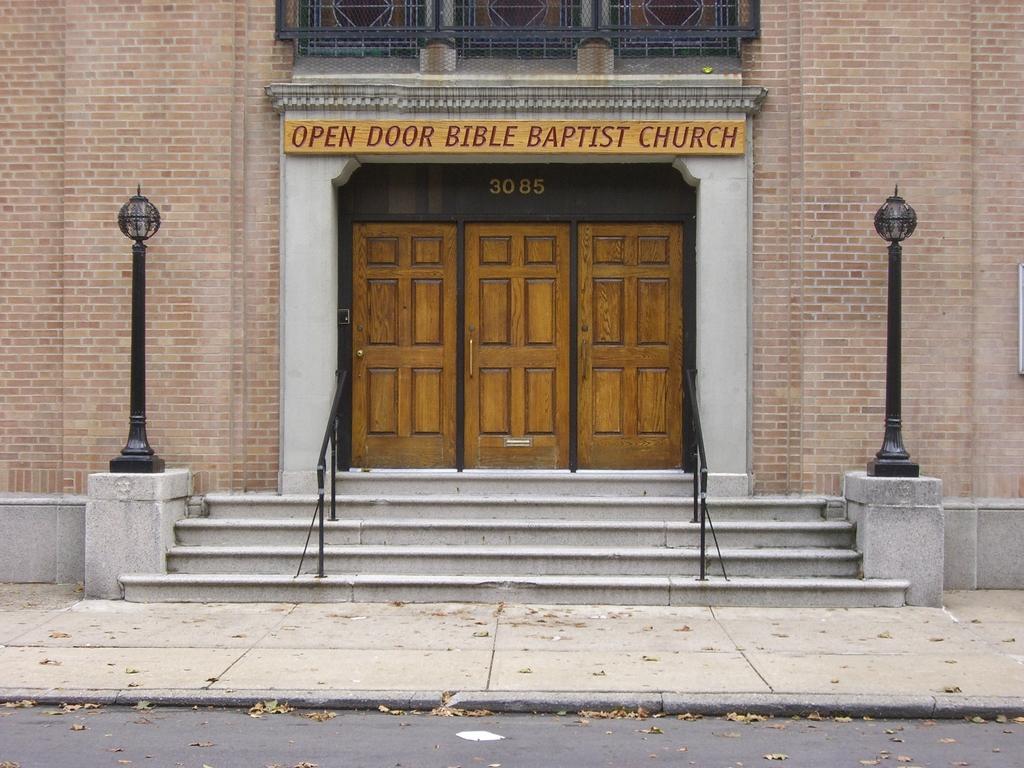Could you give a brief overview of what you see in this image? This is a building with doors and stairs, these are lights. 